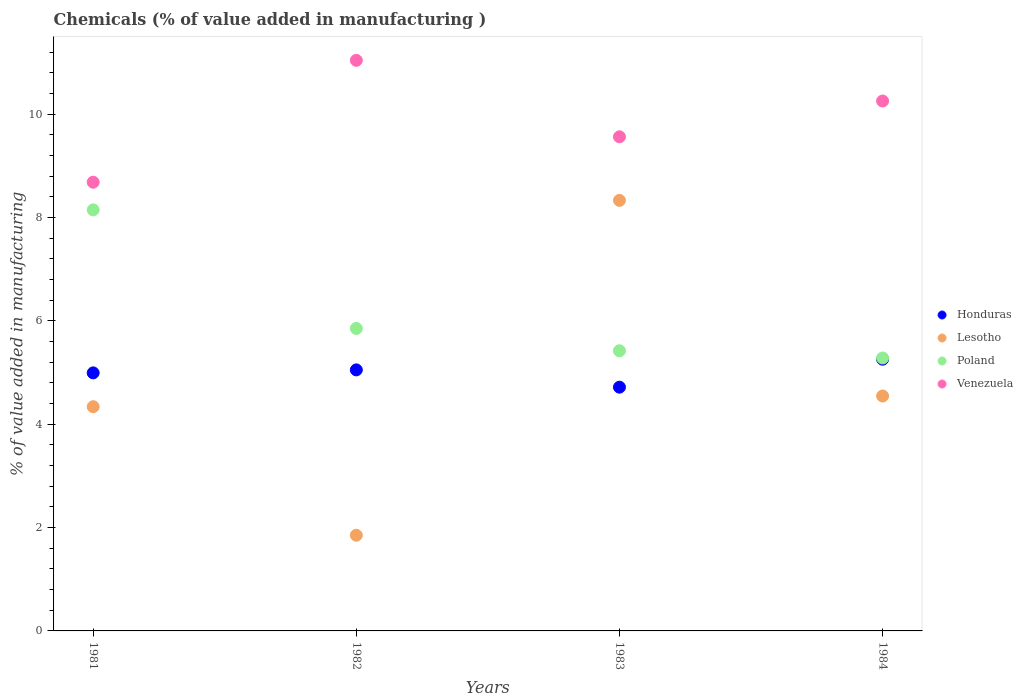How many different coloured dotlines are there?
Provide a succinct answer. 4. What is the value added in manufacturing chemicals in Lesotho in 1982?
Your answer should be compact. 1.85. Across all years, what is the maximum value added in manufacturing chemicals in Venezuela?
Offer a terse response. 11.04. Across all years, what is the minimum value added in manufacturing chemicals in Lesotho?
Offer a very short reply. 1.85. In which year was the value added in manufacturing chemicals in Poland minimum?
Make the answer very short. 1984. What is the total value added in manufacturing chemicals in Honduras in the graph?
Your answer should be compact. 20.02. What is the difference between the value added in manufacturing chemicals in Poland in 1981 and that in 1984?
Offer a terse response. 2.87. What is the difference between the value added in manufacturing chemicals in Lesotho in 1984 and the value added in manufacturing chemicals in Venezuela in 1983?
Make the answer very short. -5.02. What is the average value added in manufacturing chemicals in Honduras per year?
Your answer should be very brief. 5. In the year 1981, what is the difference between the value added in manufacturing chemicals in Venezuela and value added in manufacturing chemicals in Honduras?
Your answer should be very brief. 3.69. What is the ratio of the value added in manufacturing chemicals in Honduras in 1981 to that in 1983?
Your answer should be compact. 1.06. Is the value added in manufacturing chemicals in Poland in 1982 less than that in 1984?
Your response must be concise. No. Is the difference between the value added in manufacturing chemicals in Venezuela in 1983 and 1984 greater than the difference between the value added in manufacturing chemicals in Honduras in 1983 and 1984?
Keep it short and to the point. No. What is the difference between the highest and the second highest value added in manufacturing chemicals in Venezuela?
Provide a succinct answer. 0.79. What is the difference between the highest and the lowest value added in manufacturing chemicals in Venezuela?
Your answer should be very brief. 2.36. Is the sum of the value added in manufacturing chemicals in Honduras in 1981 and 1983 greater than the maximum value added in manufacturing chemicals in Lesotho across all years?
Give a very brief answer. Yes. Is it the case that in every year, the sum of the value added in manufacturing chemicals in Poland and value added in manufacturing chemicals in Lesotho  is greater than the sum of value added in manufacturing chemicals in Venezuela and value added in manufacturing chemicals in Honduras?
Your answer should be very brief. No. Is it the case that in every year, the sum of the value added in manufacturing chemicals in Honduras and value added in manufacturing chemicals in Lesotho  is greater than the value added in manufacturing chemicals in Poland?
Keep it short and to the point. Yes. Is the value added in manufacturing chemicals in Poland strictly greater than the value added in manufacturing chemicals in Venezuela over the years?
Make the answer very short. No. Is the value added in manufacturing chemicals in Poland strictly less than the value added in manufacturing chemicals in Lesotho over the years?
Your answer should be compact. No. How many dotlines are there?
Your answer should be very brief. 4. How many years are there in the graph?
Ensure brevity in your answer.  4. Does the graph contain any zero values?
Your answer should be compact. No. Where does the legend appear in the graph?
Your answer should be very brief. Center right. What is the title of the graph?
Your answer should be compact. Chemicals (% of value added in manufacturing ). Does "Swaziland" appear as one of the legend labels in the graph?
Offer a very short reply. No. What is the label or title of the X-axis?
Give a very brief answer. Years. What is the label or title of the Y-axis?
Your answer should be compact. % of value added in manufacturing. What is the % of value added in manufacturing in Honduras in 1981?
Provide a succinct answer. 4.99. What is the % of value added in manufacturing of Lesotho in 1981?
Make the answer very short. 4.34. What is the % of value added in manufacturing of Poland in 1981?
Give a very brief answer. 8.15. What is the % of value added in manufacturing in Venezuela in 1981?
Give a very brief answer. 8.68. What is the % of value added in manufacturing of Honduras in 1982?
Provide a succinct answer. 5.05. What is the % of value added in manufacturing in Lesotho in 1982?
Your answer should be very brief. 1.85. What is the % of value added in manufacturing in Poland in 1982?
Your answer should be very brief. 5.85. What is the % of value added in manufacturing in Venezuela in 1982?
Your response must be concise. 11.04. What is the % of value added in manufacturing in Honduras in 1983?
Ensure brevity in your answer.  4.72. What is the % of value added in manufacturing in Lesotho in 1983?
Your answer should be very brief. 8.33. What is the % of value added in manufacturing of Poland in 1983?
Ensure brevity in your answer.  5.42. What is the % of value added in manufacturing in Venezuela in 1983?
Give a very brief answer. 9.56. What is the % of value added in manufacturing of Honduras in 1984?
Your answer should be compact. 5.26. What is the % of value added in manufacturing of Lesotho in 1984?
Your answer should be very brief. 4.55. What is the % of value added in manufacturing in Poland in 1984?
Your answer should be very brief. 5.28. What is the % of value added in manufacturing of Venezuela in 1984?
Your answer should be very brief. 10.25. Across all years, what is the maximum % of value added in manufacturing in Honduras?
Provide a succinct answer. 5.26. Across all years, what is the maximum % of value added in manufacturing of Lesotho?
Your answer should be very brief. 8.33. Across all years, what is the maximum % of value added in manufacturing in Poland?
Ensure brevity in your answer.  8.15. Across all years, what is the maximum % of value added in manufacturing in Venezuela?
Your answer should be compact. 11.04. Across all years, what is the minimum % of value added in manufacturing in Honduras?
Your response must be concise. 4.72. Across all years, what is the minimum % of value added in manufacturing in Lesotho?
Provide a succinct answer. 1.85. Across all years, what is the minimum % of value added in manufacturing of Poland?
Your answer should be compact. 5.28. Across all years, what is the minimum % of value added in manufacturing in Venezuela?
Keep it short and to the point. 8.68. What is the total % of value added in manufacturing of Honduras in the graph?
Your answer should be very brief. 20.02. What is the total % of value added in manufacturing of Lesotho in the graph?
Offer a very short reply. 19.07. What is the total % of value added in manufacturing in Poland in the graph?
Your answer should be compact. 24.7. What is the total % of value added in manufacturing in Venezuela in the graph?
Your response must be concise. 39.54. What is the difference between the % of value added in manufacturing in Honduras in 1981 and that in 1982?
Keep it short and to the point. -0.06. What is the difference between the % of value added in manufacturing in Lesotho in 1981 and that in 1982?
Give a very brief answer. 2.49. What is the difference between the % of value added in manufacturing in Poland in 1981 and that in 1982?
Provide a short and direct response. 2.29. What is the difference between the % of value added in manufacturing in Venezuela in 1981 and that in 1982?
Give a very brief answer. -2.36. What is the difference between the % of value added in manufacturing of Honduras in 1981 and that in 1983?
Ensure brevity in your answer.  0.28. What is the difference between the % of value added in manufacturing in Lesotho in 1981 and that in 1983?
Keep it short and to the point. -3.99. What is the difference between the % of value added in manufacturing in Poland in 1981 and that in 1983?
Offer a terse response. 2.73. What is the difference between the % of value added in manufacturing in Venezuela in 1981 and that in 1983?
Your response must be concise. -0.88. What is the difference between the % of value added in manufacturing in Honduras in 1981 and that in 1984?
Ensure brevity in your answer.  -0.26. What is the difference between the % of value added in manufacturing of Lesotho in 1981 and that in 1984?
Provide a short and direct response. -0.21. What is the difference between the % of value added in manufacturing in Poland in 1981 and that in 1984?
Your answer should be very brief. 2.87. What is the difference between the % of value added in manufacturing in Venezuela in 1981 and that in 1984?
Your answer should be compact. -1.57. What is the difference between the % of value added in manufacturing in Honduras in 1982 and that in 1983?
Your response must be concise. 0.33. What is the difference between the % of value added in manufacturing in Lesotho in 1982 and that in 1983?
Keep it short and to the point. -6.48. What is the difference between the % of value added in manufacturing in Poland in 1982 and that in 1983?
Make the answer very short. 0.43. What is the difference between the % of value added in manufacturing in Venezuela in 1982 and that in 1983?
Provide a short and direct response. 1.48. What is the difference between the % of value added in manufacturing of Honduras in 1982 and that in 1984?
Provide a short and direct response. -0.21. What is the difference between the % of value added in manufacturing in Lesotho in 1982 and that in 1984?
Your answer should be very brief. -2.69. What is the difference between the % of value added in manufacturing in Poland in 1982 and that in 1984?
Make the answer very short. 0.57. What is the difference between the % of value added in manufacturing in Venezuela in 1982 and that in 1984?
Provide a short and direct response. 0.79. What is the difference between the % of value added in manufacturing in Honduras in 1983 and that in 1984?
Provide a short and direct response. -0.54. What is the difference between the % of value added in manufacturing in Lesotho in 1983 and that in 1984?
Ensure brevity in your answer.  3.79. What is the difference between the % of value added in manufacturing in Poland in 1983 and that in 1984?
Offer a terse response. 0.14. What is the difference between the % of value added in manufacturing in Venezuela in 1983 and that in 1984?
Your response must be concise. -0.69. What is the difference between the % of value added in manufacturing of Honduras in 1981 and the % of value added in manufacturing of Lesotho in 1982?
Make the answer very short. 3.14. What is the difference between the % of value added in manufacturing of Honduras in 1981 and the % of value added in manufacturing of Poland in 1982?
Ensure brevity in your answer.  -0.86. What is the difference between the % of value added in manufacturing in Honduras in 1981 and the % of value added in manufacturing in Venezuela in 1982?
Your answer should be very brief. -6.05. What is the difference between the % of value added in manufacturing in Lesotho in 1981 and the % of value added in manufacturing in Poland in 1982?
Make the answer very short. -1.51. What is the difference between the % of value added in manufacturing in Lesotho in 1981 and the % of value added in manufacturing in Venezuela in 1982?
Your answer should be very brief. -6.7. What is the difference between the % of value added in manufacturing in Poland in 1981 and the % of value added in manufacturing in Venezuela in 1982?
Offer a very short reply. -2.89. What is the difference between the % of value added in manufacturing in Honduras in 1981 and the % of value added in manufacturing in Lesotho in 1983?
Give a very brief answer. -3.34. What is the difference between the % of value added in manufacturing of Honduras in 1981 and the % of value added in manufacturing of Poland in 1983?
Offer a terse response. -0.43. What is the difference between the % of value added in manufacturing of Honduras in 1981 and the % of value added in manufacturing of Venezuela in 1983?
Give a very brief answer. -4.57. What is the difference between the % of value added in manufacturing of Lesotho in 1981 and the % of value added in manufacturing of Poland in 1983?
Ensure brevity in your answer.  -1.08. What is the difference between the % of value added in manufacturing of Lesotho in 1981 and the % of value added in manufacturing of Venezuela in 1983?
Offer a terse response. -5.22. What is the difference between the % of value added in manufacturing in Poland in 1981 and the % of value added in manufacturing in Venezuela in 1983?
Your answer should be very brief. -1.41. What is the difference between the % of value added in manufacturing in Honduras in 1981 and the % of value added in manufacturing in Lesotho in 1984?
Your response must be concise. 0.45. What is the difference between the % of value added in manufacturing in Honduras in 1981 and the % of value added in manufacturing in Poland in 1984?
Your answer should be very brief. -0.29. What is the difference between the % of value added in manufacturing in Honduras in 1981 and the % of value added in manufacturing in Venezuela in 1984?
Your response must be concise. -5.26. What is the difference between the % of value added in manufacturing in Lesotho in 1981 and the % of value added in manufacturing in Poland in 1984?
Your answer should be very brief. -0.94. What is the difference between the % of value added in manufacturing of Lesotho in 1981 and the % of value added in manufacturing of Venezuela in 1984?
Provide a succinct answer. -5.92. What is the difference between the % of value added in manufacturing in Poland in 1981 and the % of value added in manufacturing in Venezuela in 1984?
Offer a terse response. -2.11. What is the difference between the % of value added in manufacturing in Honduras in 1982 and the % of value added in manufacturing in Lesotho in 1983?
Provide a succinct answer. -3.28. What is the difference between the % of value added in manufacturing of Honduras in 1982 and the % of value added in manufacturing of Poland in 1983?
Give a very brief answer. -0.37. What is the difference between the % of value added in manufacturing of Honduras in 1982 and the % of value added in manufacturing of Venezuela in 1983?
Make the answer very short. -4.51. What is the difference between the % of value added in manufacturing of Lesotho in 1982 and the % of value added in manufacturing of Poland in 1983?
Provide a succinct answer. -3.57. What is the difference between the % of value added in manufacturing in Lesotho in 1982 and the % of value added in manufacturing in Venezuela in 1983?
Your response must be concise. -7.71. What is the difference between the % of value added in manufacturing in Poland in 1982 and the % of value added in manufacturing in Venezuela in 1983?
Offer a terse response. -3.71. What is the difference between the % of value added in manufacturing of Honduras in 1982 and the % of value added in manufacturing of Lesotho in 1984?
Your answer should be very brief. 0.51. What is the difference between the % of value added in manufacturing in Honduras in 1982 and the % of value added in manufacturing in Poland in 1984?
Offer a terse response. -0.23. What is the difference between the % of value added in manufacturing of Honduras in 1982 and the % of value added in manufacturing of Venezuela in 1984?
Offer a terse response. -5.2. What is the difference between the % of value added in manufacturing of Lesotho in 1982 and the % of value added in manufacturing of Poland in 1984?
Provide a succinct answer. -3.43. What is the difference between the % of value added in manufacturing of Lesotho in 1982 and the % of value added in manufacturing of Venezuela in 1984?
Your answer should be compact. -8.4. What is the difference between the % of value added in manufacturing of Poland in 1982 and the % of value added in manufacturing of Venezuela in 1984?
Offer a very short reply. -4.4. What is the difference between the % of value added in manufacturing of Honduras in 1983 and the % of value added in manufacturing of Lesotho in 1984?
Provide a succinct answer. 0.17. What is the difference between the % of value added in manufacturing of Honduras in 1983 and the % of value added in manufacturing of Poland in 1984?
Give a very brief answer. -0.56. What is the difference between the % of value added in manufacturing of Honduras in 1983 and the % of value added in manufacturing of Venezuela in 1984?
Provide a succinct answer. -5.54. What is the difference between the % of value added in manufacturing of Lesotho in 1983 and the % of value added in manufacturing of Poland in 1984?
Your answer should be very brief. 3.05. What is the difference between the % of value added in manufacturing of Lesotho in 1983 and the % of value added in manufacturing of Venezuela in 1984?
Your response must be concise. -1.92. What is the difference between the % of value added in manufacturing of Poland in 1983 and the % of value added in manufacturing of Venezuela in 1984?
Offer a very short reply. -4.83. What is the average % of value added in manufacturing in Honduras per year?
Keep it short and to the point. 5. What is the average % of value added in manufacturing in Lesotho per year?
Provide a short and direct response. 4.77. What is the average % of value added in manufacturing in Poland per year?
Ensure brevity in your answer.  6.18. What is the average % of value added in manufacturing of Venezuela per year?
Offer a very short reply. 9.89. In the year 1981, what is the difference between the % of value added in manufacturing of Honduras and % of value added in manufacturing of Lesotho?
Offer a very short reply. 0.65. In the year 1981, what is the difference between the % of value added in manufacturing in Honduras and % of value added in manufacturing in Poland?
Your answer should be very brief. -3.15. In the year 1981, what is the difference between the % of value added in manufacturing of Honduras and % of value added in manufacturing of Venezuela?
Your answer should be very brief. -3.69. In the year 1981, what is the difference between the % of value added in manufacturing of Lesotho and % of value added in manufacturing of Poland?
Ensure brevity in your answer.  -3.81. In the year 1981, what is the difference between the % of value added in manufacturing in Lesotho and % of value added in manufacturing in Venezuela?
Your answer should be very brief. -4.34. In the year 1981, what is the difference between the % of value added in manufacturing of Poland and % of value added in manufacturing of Venezuela?
Offer a terse response. -0.54. In the year 1982, what is the difference between the % of value added in manufacturing in Honduras and % of value added in manufacturing in Lesotho?
Keep it short and to the point. 3.2. In the year 1982, what is the difference between the % of value added in manufacturing in Honduras and % of value added in manufacturing in Poland?
Provide a succinct answer. -0.8. In the year 1982, what is the difference between the % of value added in manufacturing in Honduras and % of value added in manufacturing in Venezuela?
Provide a succinct answer. -5.99. In the year 1982, what is the difference between the % of value added in manufacturing of Lesotho and % of value added in manufacturing of Poland?
Provide a short and direct response. -4. In the year 1982, what is the difference between the % of value added in manufacturing of Lesotho and % of value added in manufacturing of Venezuela?
Provide a succinct answer. -9.19. In the year 1982, what is the difference between the % of value added in manufacturing of Poland and % of value added in manufacturing of Venezuela?
Offer a terse response. -5.19. In the year 1983, what is the difference between the % of value added in manufacturing in Honduras and % of value added in manufacturing in Lesotho?
Provide a short and direct response. -3.62. In the year 1983, what is the difference between the % of value added in manufacturing of Honduras and % of value added in manufacturing of Poland?
Your answer should be very brief. -0.7. In the year 1983, what is the difference between the % of value added in manufacturing of Honduras and % of value added in manufacturing of Venezuela?
Provide a succinct answer. -4.85. In the year 1983, what is the difference between the % of value added in manufacturing of Lesotho and % of value added in manufacturing of Poland?
Provide a succinct answer. 2.91. In the year 1983, what is the difference between the % of value added in manufacturing of Lesotho and % of value added in manufacturing of Venezuela?
Your answer should be compact. -1.23. In the year 1983, what is the difference between the % of value added in manufacturing in Poland and % of value added in manufacturing in Venezuela?
Provide a succinct answer. -4.14. In the year 1984, what is the difference between the % of value added in manufacturing of Honduras and % of value added in manufacturing of Lesotho?
Provide a short and direct response. 0.71. In the year 1984, what is the difference between the % of value added in manufacturing in Honduras and % of value added in manufacturing in Poland?
Ensure brevity in your answer.  -0.02. In the year 1984, what is the difference between the % of value added in manufacturing in Honduras and % of value added in manufacturing in Venezuela?
Provide a succinct answer. -5. In the year 1984, what is the difference between the % of value added in manufacturing in Lesotho and % of value added in manufacturing in Poland?
Make the answer very short. -0.74. In the year 1984, what is the difference between the % of value added in manufacturing of Lesotho and % of value added in manufacturing of Venezuela?
Provide a short and direct response. -5.71. In the year 1984, what is the difference between the % of value added in manufacturing in Poland and % of value added in manufacturing in Venezuela?
Give a very brief answer. -4.97. What is the ratio of the % of value added in manufacturing in Honduras in 1981 to that in 1982?
Ensure brevity in your answer.  0.99. What is the ratio of the % of value added in manufacturing of Lesotho in 1981 to that in 1982?
Offer a terse response. 2.34. What is the ratio of the % of value added in manufacturing of Poland in 1981 to that in 1982?
Provide a short and direct response. 1.39. What is the ratio of the % of value added in manufacturing of Venezuela in 1981 to that in 1982?
Your answer should be very brief. 0.79. What is the ratio of the % of value added in manufacturing of Honduras in 1981 to that in 1983?
Provide a short and direct response. 1.06. What is the ratio of the % of value added in manufacturing in Lesotho in 1981 to that in 1983?
Keep it short and to the point. 0.52. What is the ratio of the % of value added in manufacturing of Poland in 1981 to that in 1983?
Your answer should be compact. 1.5. What is the ratio of the % of value added in manufacturing of Venezuela in 1981 to that in 1983?
Keep it short and to the point. 0.91. What is the ratio of the % of value added in manufacturing in Honduras in 1981 to that in 1984?
Give a very brief answer. 0.95. What is the ratio of the % of value added in manufacturing in Lesotho in 1981 to that in 1984?
Offer a very short reply. 0.95. What is the ratio of the % of value added in manufacturing in Poland in 1981 to that in 1984?
Give a very brief answer. 1.54. What is the ratio of the % of value added in manufacturing in Venezuela in 1981 to that in 1984?
Give a very brief answer. 0.85. What is the ratio of the % of value added in manufacturing of Honduras in 1982 to that in 1983?
Make the answer very short. 1.07. What is the ratio of the % of value added in manufacturing in Lesotho in 1982 to that in 1983?
Provide a succinct answer. 0.22. What is the ratio of the % of value added in manufacturing in Poland in 1982 to that in 1983?
Make the answer very short. 1.08. What is the ratio of the % of value added in manufacturing of Venezuela in 1982 to that in 1983?
Make the answer very short. 1.15. What is the ratio of the % of value added in manufacturing of Honduras in 1982 to that in 1984?
Your answer should be very brief. 0.96. What is the ratio of the % of value added in manufacturing in Lesotho in 1982 to that in 1984?
Offer a very short reply. 0.41. What is the ratio of the % of value added in manufacturing in Poland in 1982 to that in 1984?
Your answer should be compact. 1.11. What is the ratio of the % of value added in manufacturing in Venezuela in 1982 to that in 1984?
Your answer should be compact. 1.08. What is the ratio of the % of value added in manufacturing of Honduras in 1983 to that in 1984?
Your response must be concise. 0.9. What is the ratio of the % of value added in manufacturing in Lesotho in 1983 to that in 1984?
Ensure brevity in your answer.  1.83. What is the ratio of the % of value added in manufacturing in Poland in 1983 to that in 1984?
Provide a succinct answer. 1.03. What is the ratio of the % of value added in manufacturing in Venezuela in 1983 to that in 1984?
Ensure brevity in your answer.  0.93. What is the difference between the highest and the second highest % of value added in manufacturing of Honduras?
Make the answer very short. 0.21. What is the difference between the highest and the second highest % of value added in manufacturing of Lesotho?
Keep it short and to the point. 3.79. What is the difference between the highest and the second highest % of value added in manufacturing in Poland?
Offer a terse response. 2.29. What is the difference between the highest and the second highest % of value added in manufacturing of Venezuela?
Your answer should be very brief. 0.79. What is the difference between the highest and the lowest % of value added in manufacturing in Honduras?
Make the answer very short. 0.54. What is the difference between the highest and the lowest % of value added in manufacturing in Lesotho?
Your answer should be compact. 6.48. What is the difference between the highest and the lowest % of value added in manufacturing in Poland?
Ensure brevity in your answer.  2.87. What is the difference between the highest and the lowest % of value added in manufacturing in Venezuela?
Offer a terse response. 2.36. 